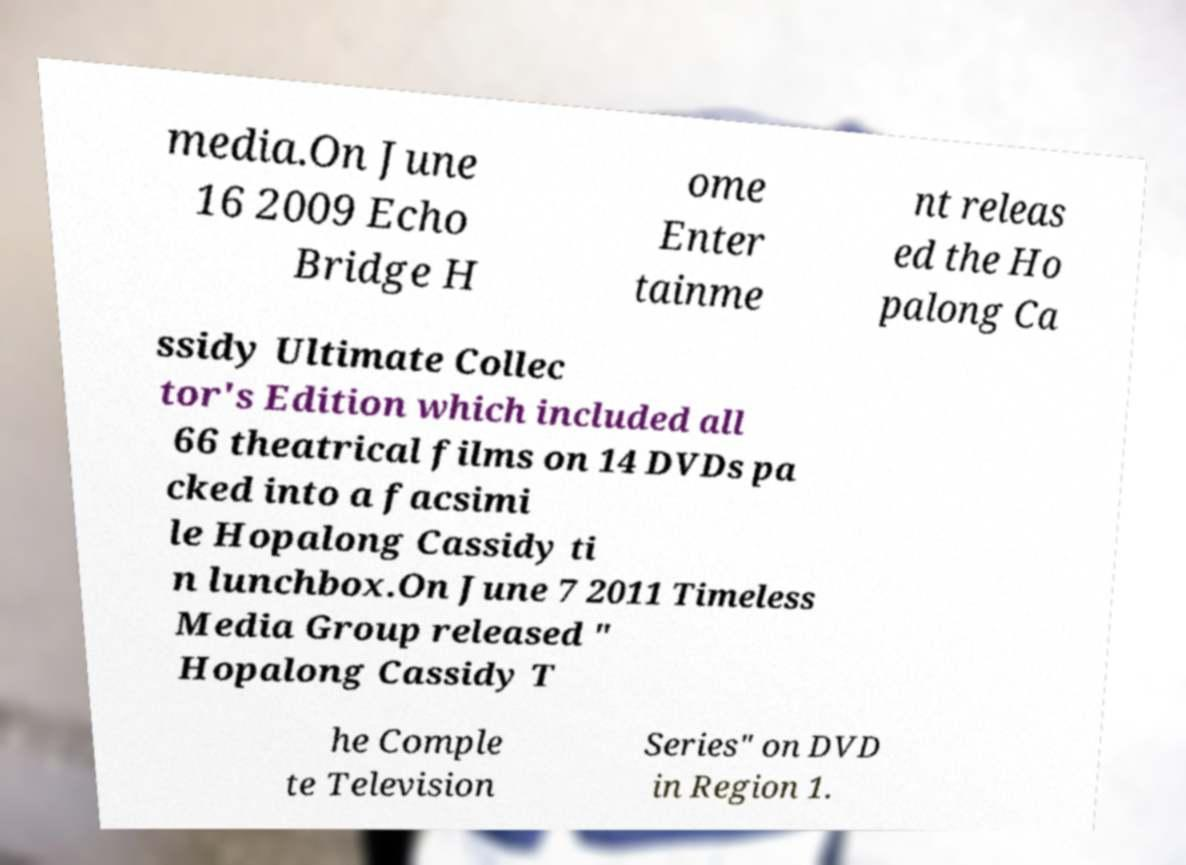Can you accurately transcribe the text from the provided image for me? media.On June 16 2009 Echo Bridge H ome Enter tainme nt releas ed the Ho palong Ca ssidy Ultimate Collec tor's Edition which included all 66 theatrical films on 14 DVDs pa cked into a facsimi le Hopalong Cassidy ti n lunchbox.On June 7 2011 Timeless Media Group released " Hopalong Cassidy T he Comple te Television Series" on DVD in Region 1. 